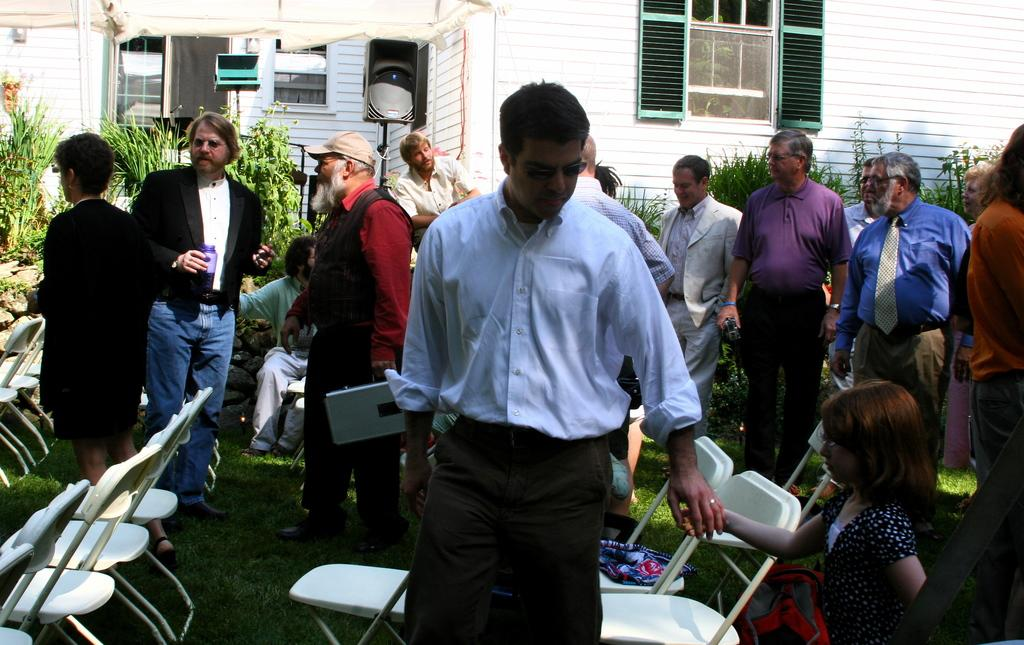What can be seen in the image? There are people standing in the image. What type of furniture is present in the image? There are white chairs in the image. What is the ground surface like in the image? There is grass visible in the image. What can be seen in the distance in the image? There are buildings and plants in the background of the image. What type of lace is being used to decorate the buildings in the image? There is no lace visible in the image, as it focuses on people, chairs, grass, and the background. 